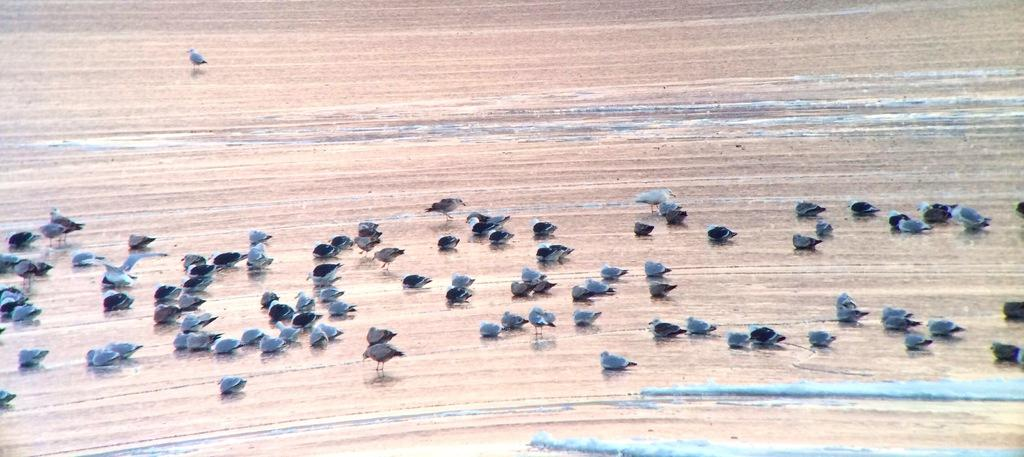What is the primary element visible in the image? There is water visible in the image. What type of animals can be seen in the image? There are many birds in the image. What type of jeans can be seen on the birds in the image? There are no jeans present in the image; the birds are not wearing any clothing. 